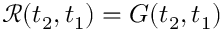<formula> <loc_0><loc_0><loc_500><loc_500>\mathcal { R } ( t _ { 2 } , t _ { 1 } ) = G ( t _ { 2 } , t _ { 1 } )</formula> 